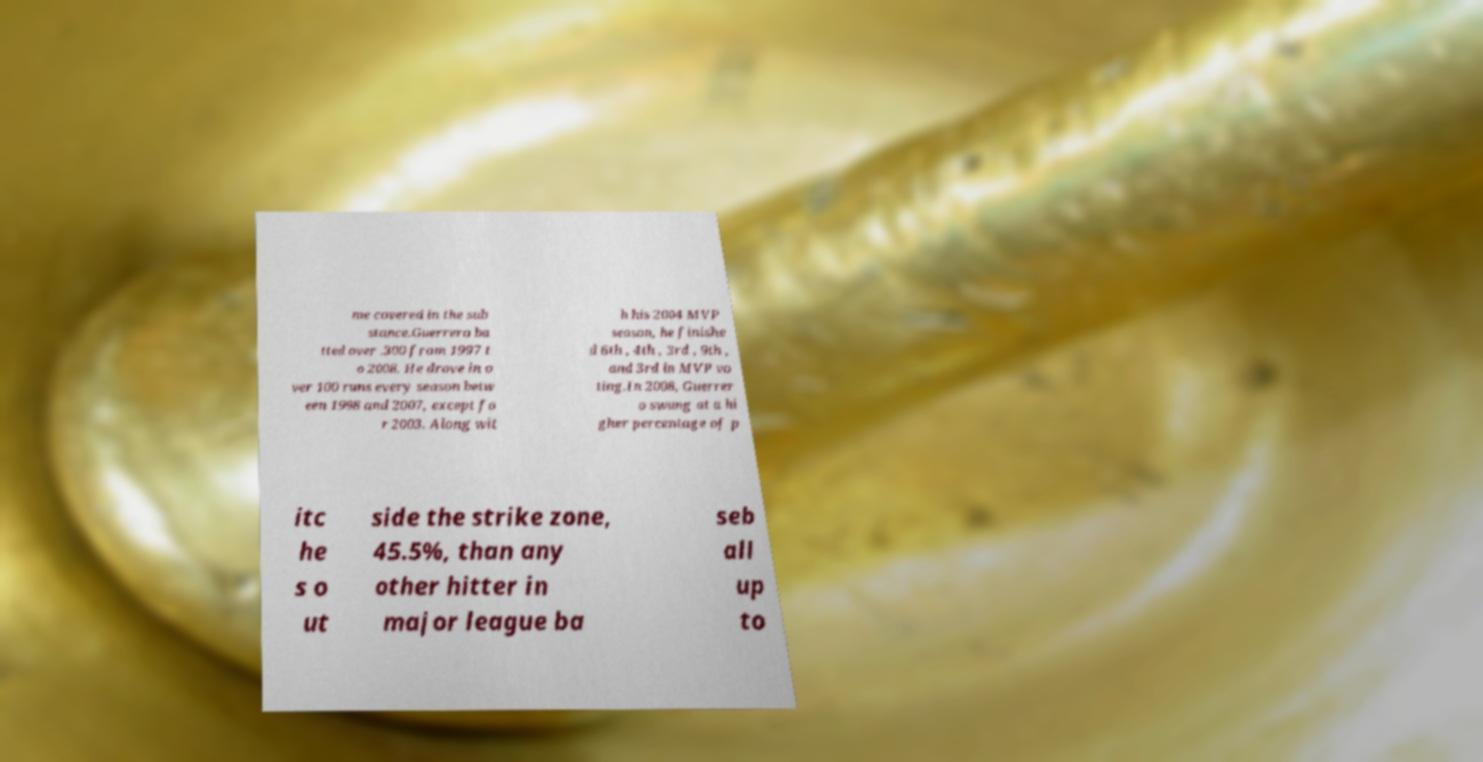I need the written content from this picture converted into text. Can you do that? me covered in the sub stance.Guerrero ba tted over .300 from 1997 t o 2008. He drove in o ver 100 runs every season betw een 1998 and 2007, except fo r 2003. Along wit h his 2004 MVP season, he finishe d 6th , 4th , 3rd , 9th , and 3rd in MVP vo ting.In 2008, Guerrer o swung at a hi gher percentage of p itc he s o ut side the strike zone, 45.5%, than any other hitter in major league ba seb all up to 